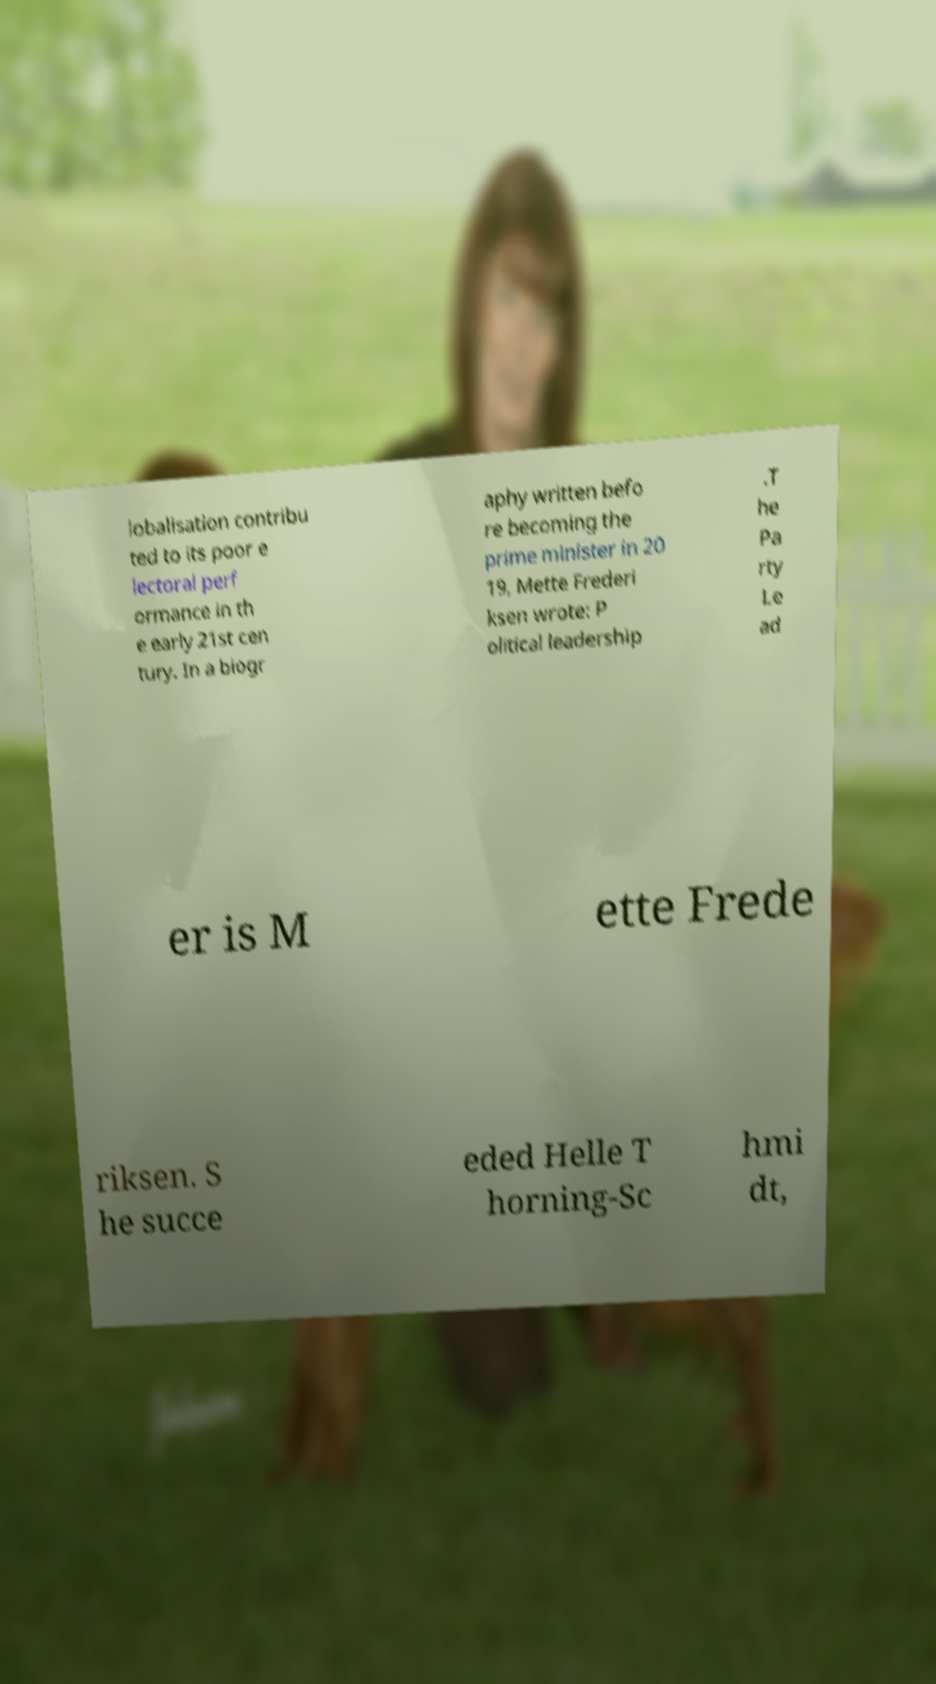What messages or text are displayed in this image? I need them in a readable, typed format. lobalisation contribu ted to its poor e lectoral perf ormance in th e early 21st cen tury. In a biogr aphy written befo re becoming the prime minister in 20 19, Mette Frederi ksen wrote: P olitical leadership .T he Pa rty Le ad er is M ette Frede riksen. S he succe eded Helle T horning-Sc hmi dt, 